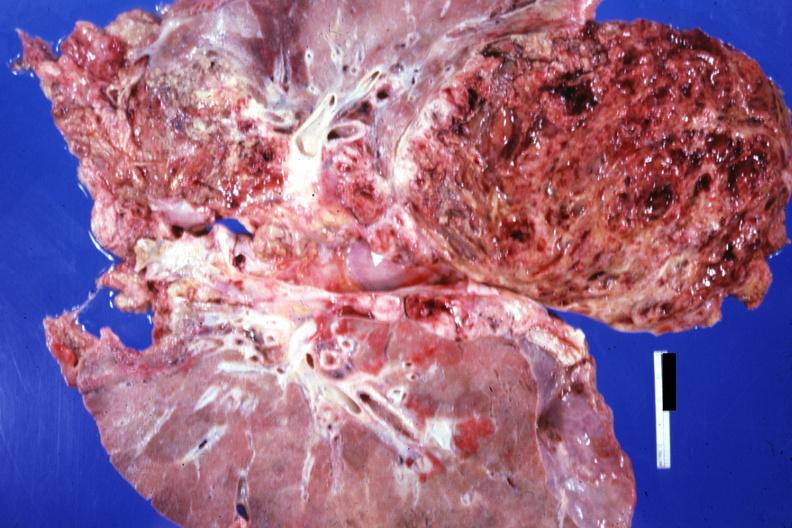s intestine present?
Answer the question using a single word or phrase. No 